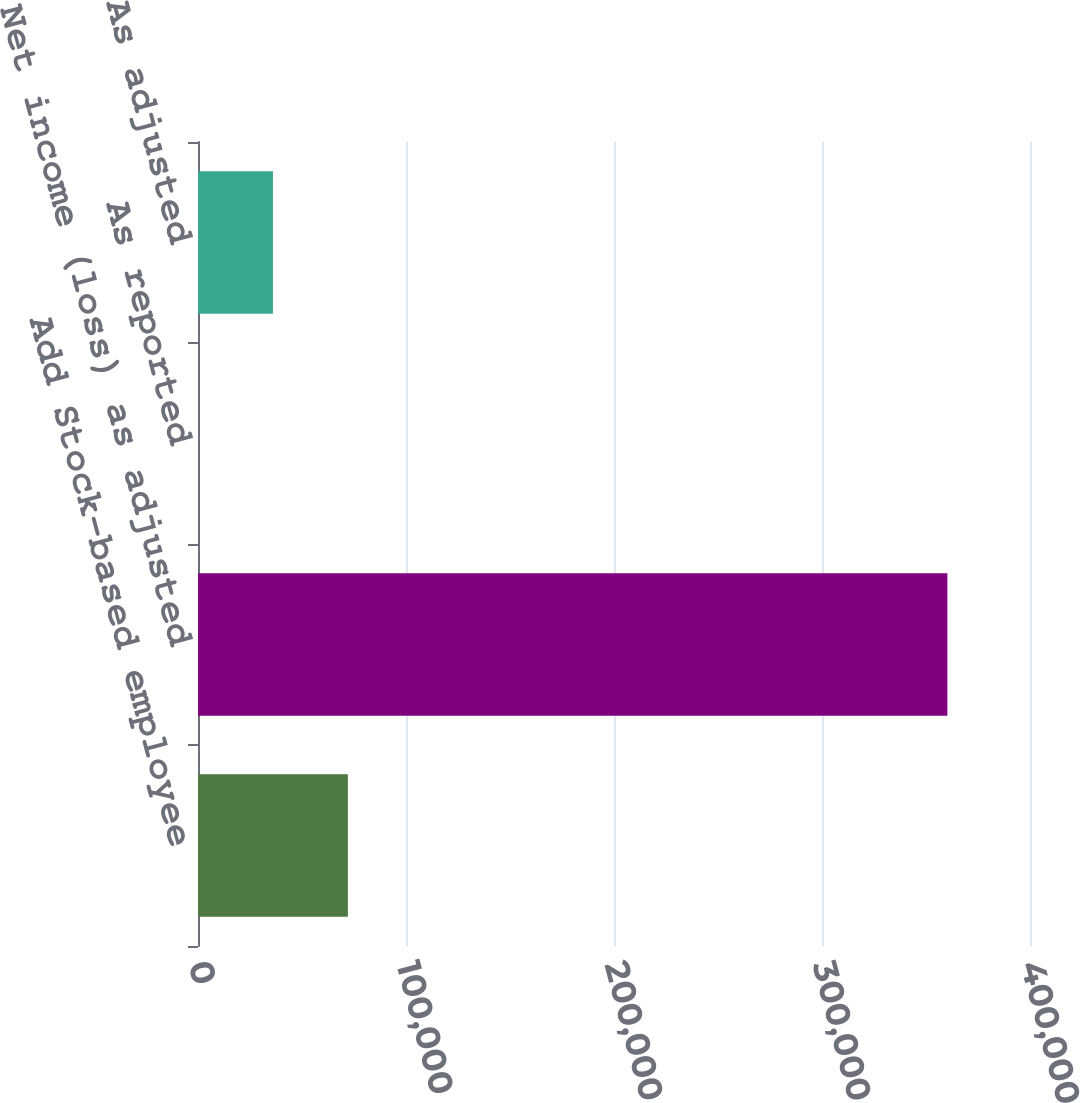Convert chart. <chart><loc_0><loc_0><loc_500><loc_500><bar_chart><fcel>Add Stock-based employee<fcel>Net income (loss) as adjusted<fcel>As reported<fcel>As adjusted<nl><fcel>72057.3<fcel>360281<fcel>1.39<fcel>36029.3<nl></chart> 